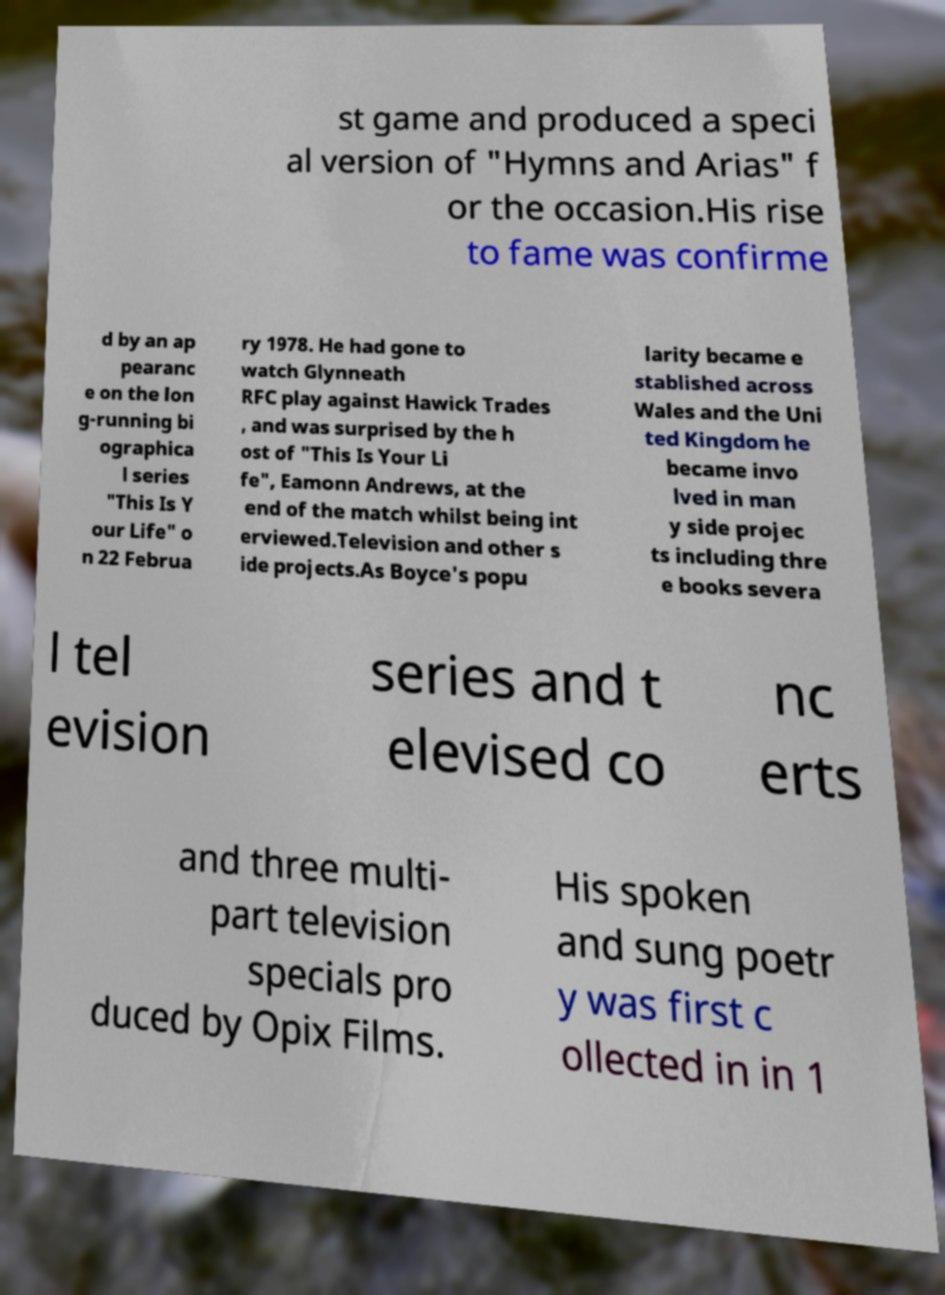I need the written content from this picture converted into text. Can you do that? st game and produced a speci al version of "Hymns and Arias" f or the occasion.His rise to fame was confirme d by an ap pearanc e on the lon g-running bi ographica l series "This Is Y our Life" o n 22 Februa ry 1978. He had gone to watch Glynneath RFC play against Hawick Trades , and was surprised by the h ost of "This Is Your Li fe", Eamonn Andrews, at the end of the match whilst being int erviewed.Television and other s ide projects.As Boyce's popu larity became e stablished across Wales and the Uni ted Kingdom he became invo lved in man y side projec ts including thre e books severa l tel evision series and t elevised co nc erts and three multi- part television specials pro duced by Opix Films. His spoken and sung poetr y was first c ollected in in 1 